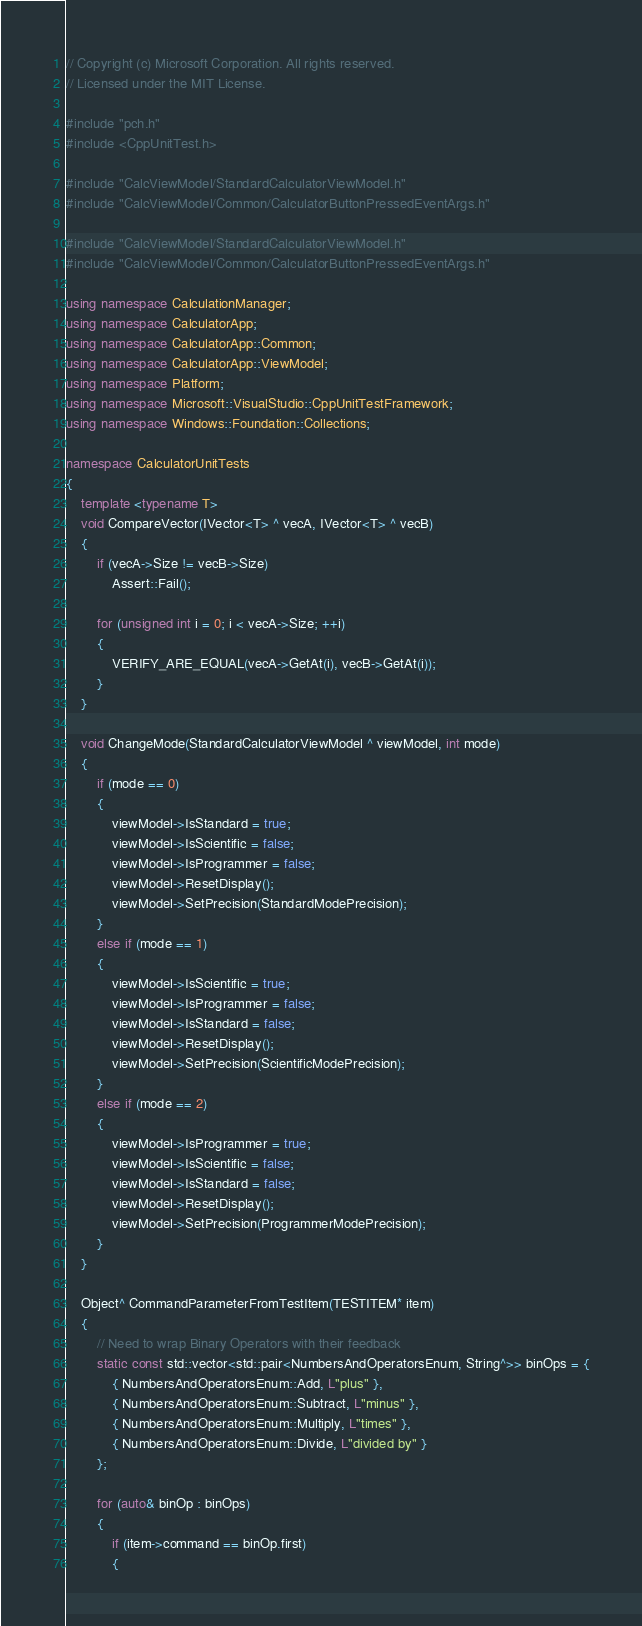<code> <loc_0><loc_0><loc_500><loc_500><_C++_>// Copyright (c) Microsoft Corporation. All rights reserved.
// Licensed under the MIT License.

#include "pch.h"
#include <CppUnitTest.h>

#include "CalcViewModel/StandardCalculatorViewModel.h"
#include "CalcViewModel/Common/CalculatorButtonPressedEventArgs.h"

#include "CalcViewModel/StandardCalculatorViewModel.h"
#include "CalcViewModel/Common/CalculatorButtonPressedEventArgs.h"

using namespace CalculationManager;
using namespace CalculatorApp;
using namespace CalculatorApp::Common;
using namespace CalculatorApp::ViewModel;
using namespace Platform;
using namespace Microsoft::VisualStudio::CppUnitTestFramework;
using namespace Windows::Foundation::Collections;

namespace CalculatorUnitTests
{
    template <typename T>
    void CompareVector(IVector<T> ^ vecA, IVector<T> ^ vecB)
    {
        if (vecA->Size != vecB->Size)
            Assert::Fail();

        for (unsigned int i = 0; i < vecA->Size; ++i)
        {
            VERIFY_ARE_EQUAL(vecA->GetAt(i), vecB->GetAt(i));
        }
    }

    void ChangeMode(StandardCalculatorViewModel ^ viewModel, int mode)
    {
        if (mode == 0)
        {
            viewModel->IsStandard = true;
            viewModel->IsScientific = false;
            viewModel->IsProgrammer = false;
            viewModel->ResetDisplay();
            viewModel->SetPrecision(StandardModePrecision);
        }
        else if (mode == 1)
        {
            viewModel->IsScientific = true;
            viewModel->IsProgrammer = false;
            viewModel->IsStandard = false;
            viewModel->ResetDisplay();
            viewModel->SetPrecision(ScientificModePrecision);
        }
        else if (mode == 2)
        {
            viewModel->IsProgrammer = true;
            viewModel->IsScientific = false;
            viewModel->IsStandard = false;
            viewModel->ResetDisplay();
            viewModel->SetPrecision(ProgrammerModePrecision);
        }
    }

    Object^ CommandParameterFromTestItem(TESTITEM* item)
    {
        // Need to wrap Binary Operators with their feedback
        static const std::vector<std::pair<NumbersAndOperatorsEnum, String^>> binOps = {
            { NumbersAndOperatorsEnum::Add, L"plus" },
            { NumbersAndOperatorsEnum::Subtract, L"minus" },
            { NumbersAndOperatorsEnum::Multiply, L"times" },
            { NumbersAndOperatorsEnum::Divide, L"divided by" }
        };

        for (auto& binOp : binOps)
        {
            if (item->command == binOp.first)
            {</code> 